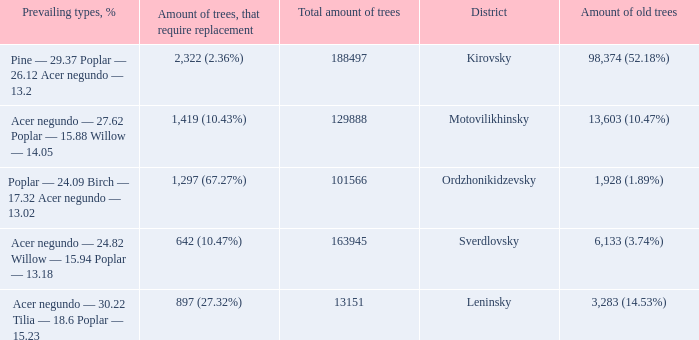What is the amount of trees, that require replacement when prevailing types, % is pine — 29.37 poplar — 26.12 acer negundo — 13.2? 2,322 (2.36%). 